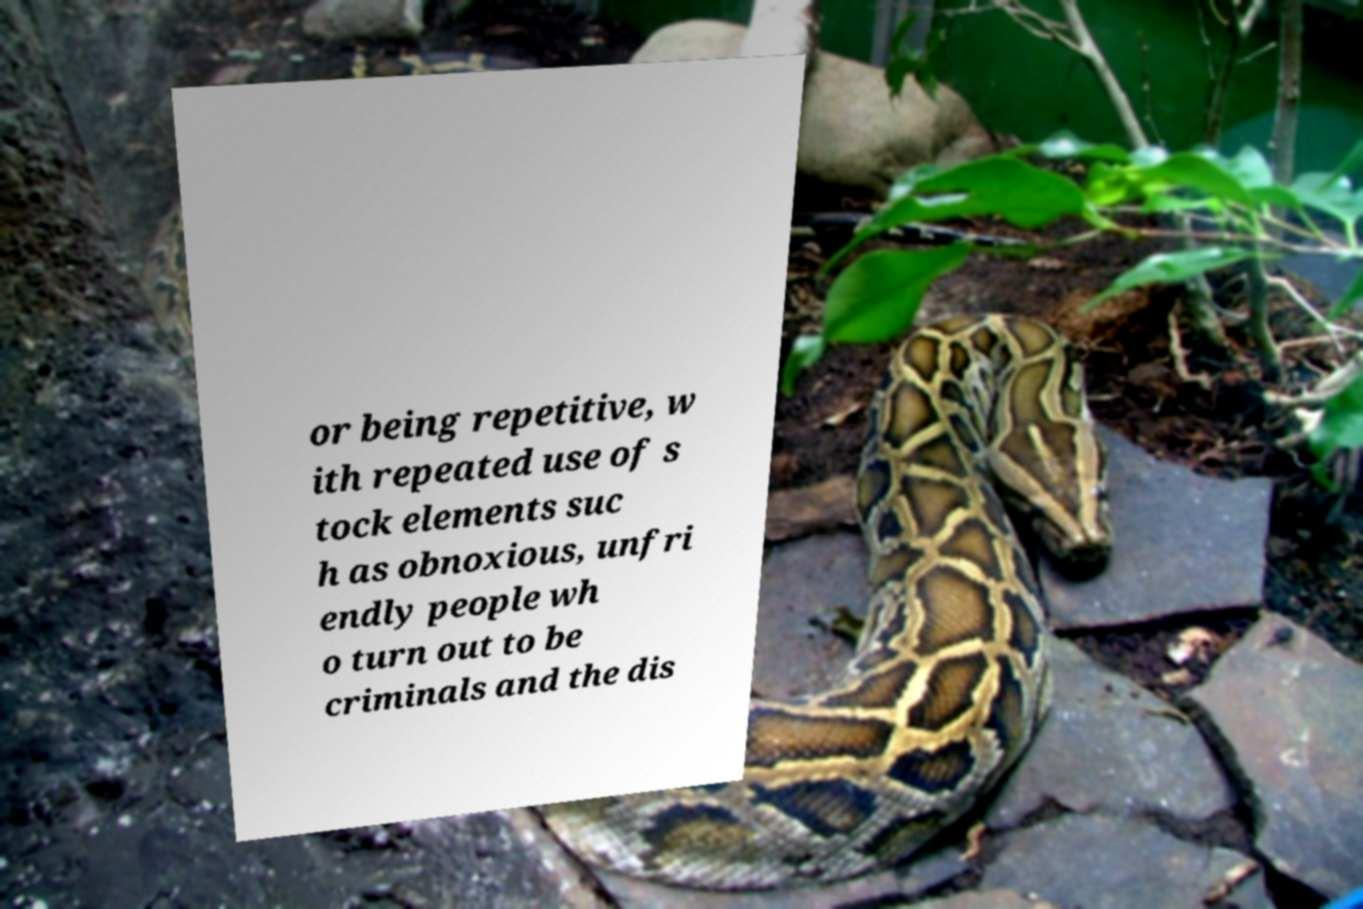For documentation purposes, I need the text within this image transcribed. Could you provide that? or being repetitive, w ith repeated use of s tock elements suc h as obnoxious, unfri endly people wh o turn out to be criminals and the dis 